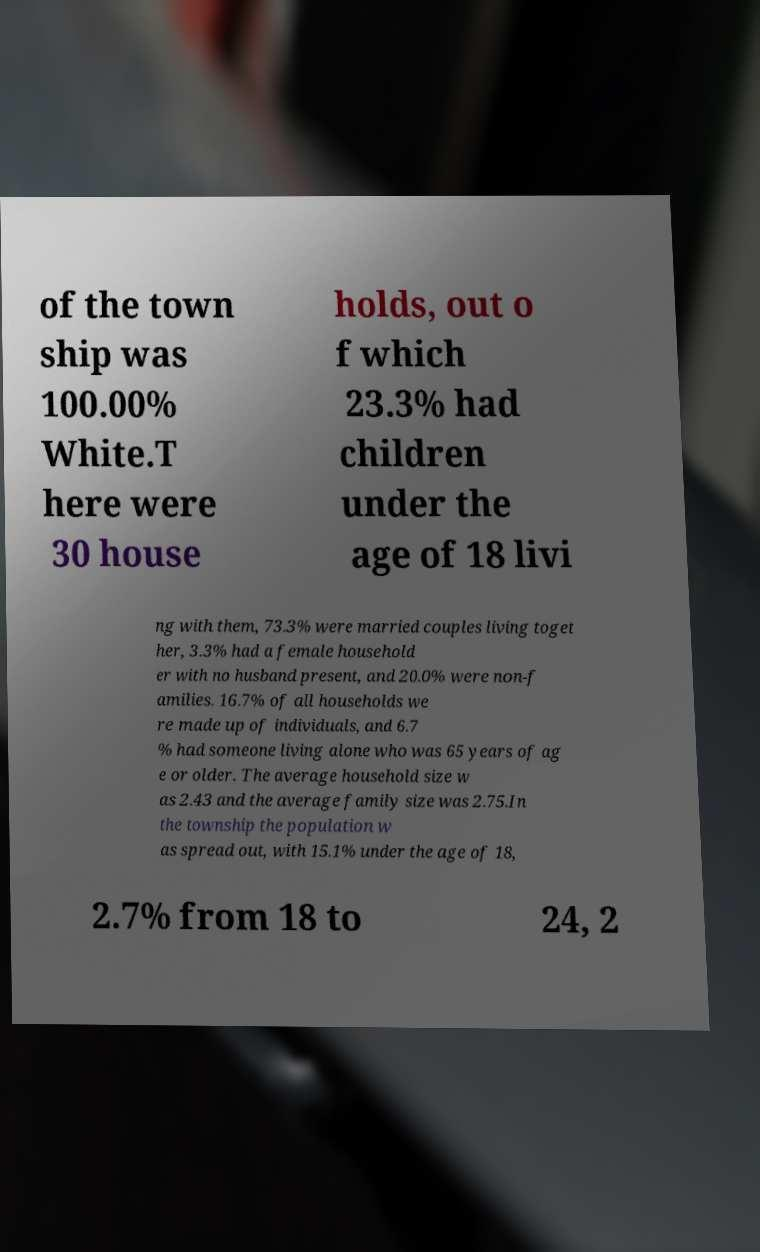For documentation purposes, I need the text within this image transcribed. Could you provide that? of the town ship was 100.00% White.T here were 30 house holds, out o f which 23.3% had children under the age of 18 livi ng with them, 73.3% were married couples living toget her, 3.3% had a female household er with no husband present, and 20.0% were non-f amilies. 16.7% of all households we re made up of individuals, and 6.7 % had someone living alone who was 65 years of ag e or older. The average household size w as 2.43 and the average family size was 2.75.In the township the population w as spread out, with 15.1% under the age of 18, 2.7% from 18 to 24, 2 